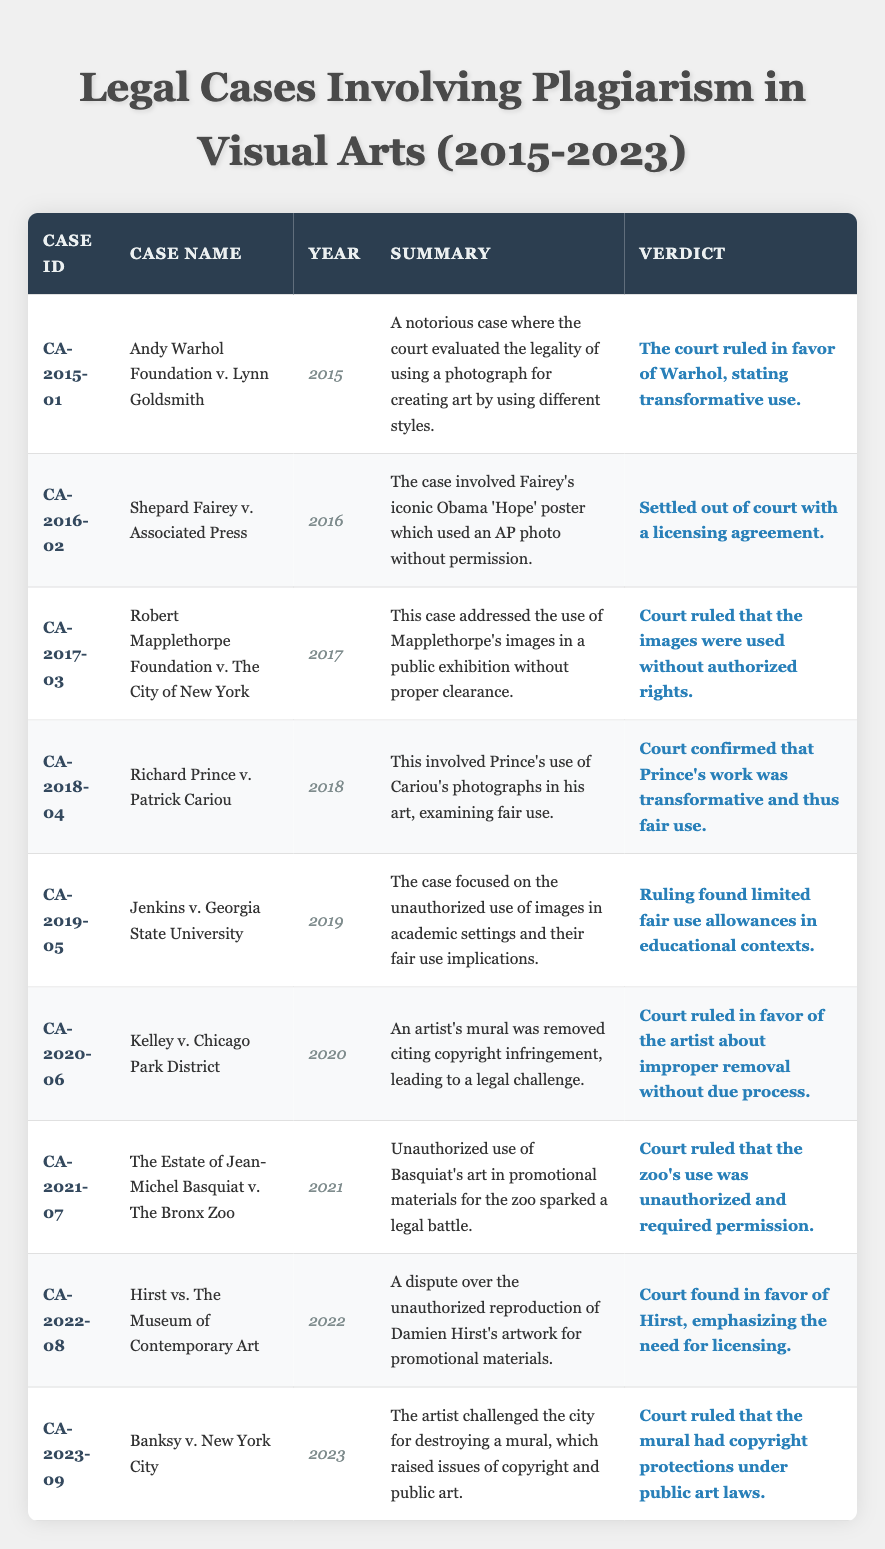What year was the case "Jenkins v. Georgia State University" decided? The case "Jenkins v. Georgia State University" is listed in the table with its year indicated in the "Year" column, showing it was decided in 2019.
Answer: 2019 Which case had a verdict stating that the use was unauthorized? By checking the "Verdict" column, we see that "Robert Mapplethorpe Foundation v. The City of New York" has a verdict that states the images were used without authorized rights.
Answer: Robert Mapplethorpe Foundation v. The City of New York How many cases were ruled in favor of the artist? By counting the rows in the table where the "Verdict" column shows that the court ruled in favor of the artist, we find three cases: "Andy Warhol Foundation v. Lynn Goldsmith," "Kelley v. Chicago Park District," and "Hirst vs. The Museum of Contemporary Art." Therefore, the total is 3.
Answer: 3 Was the verdict in the case "Banksy v. New York City" in favor of the city? The verdict for "Banksy v. New York City" indicates that the court ruled the mural had copyright protections, which suggests the ruling was not in favor of the city. Therefore, the answer is no.
Answer: No Can you summarize the number of cases involving fair use rulings? Reviewing the table, we determine that there are three cases that specifically address fair use: "Richard Prince v. Patrick Cariou," "Jenkins v. Georgia State University," and "Andy Warhol Foundation v. Lynn Goldsmith." Thus, the total is three cases concerning fair use.
Answer: 3 What is the common theme among the cases of 2016 and 2022? Analyzing the case names and summaries indicates that both cases involve unauthorized use of art for promotional purposes, hence they share a common theme of copyright infringement in a commercial context.
Answer: Unauthorized use of art for promotion Which case was decided last in this table? The last case in the table by the year is "Banksy v. New York City," which was decided in 2023. Therefore, it is the most recent case listed.
Answer: Banksy v. New York City Was any of the cases settled out of court? By looking into the "Verdict" column, we can see that "Shepard Fairey v. Associated Press" is marked as settled out of court with a licensing agreement. Therefore, the answer is yes.
Answer: Yes How many cases were related to public art? By analyzing the details in the table, we identify two cases related to public art: "Banksy v. New York City" and "Kelley v. Chicago Park District," leading to a total of two cases.
Answer: 2 